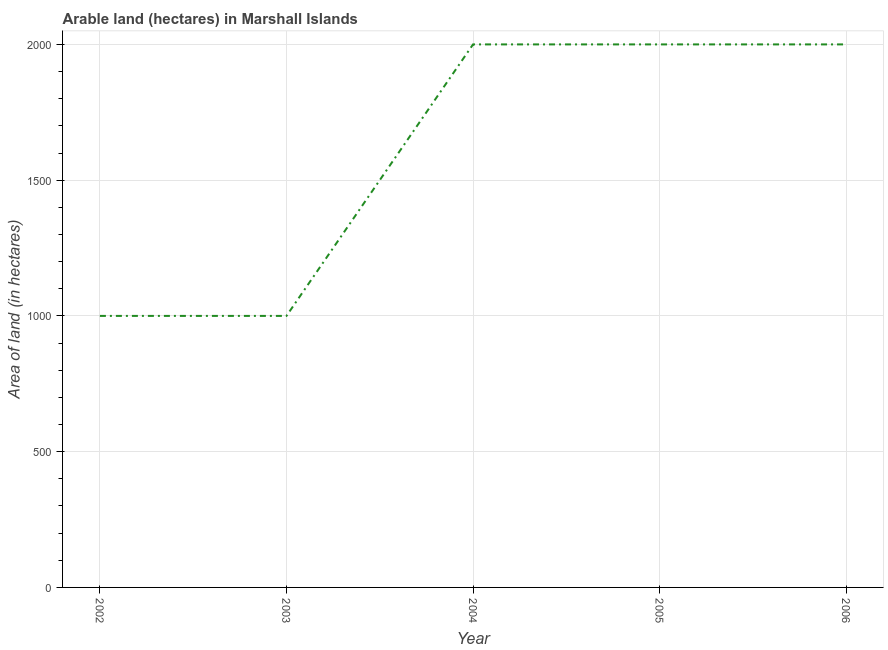What is the area of land in 2006?
Provide a succinct answer. 2000. Across all years, what is the minimum area of land?
Give a very brief answer. 1000. In which year was the area of land minimum?
Provide a succinct answer. 2002. What is the sum of the area of land?
Keep it short and to the point. 8000. What is the difference between the area of land in 2002 and 2005?
Your response must be concise. -1000. What is the average area of land per year?
Provide a short and direct response. 1600. What is the median area of land?
Offer a very short reply. 2000. In how many years, is the area of land greater than 500 hectares?
Keep it short and to the point. 5. What is the difference between the highest and the lowest area of land?
Keep it short and to the point. 1000. Does the area of land monotonically increase over the years?
Offer a very short reply. No. How many lines are there?
Provide a short and direct response. 1. Are the values on the major ticks of Y-axis written in scientific E-notation?
Provide a succinct answer. No. Does the graph contain grids?
Ensure brevity in your answer.  Yes. What is the title of the graph?
Ensure brevity in your answer.  Arable land (hectares) in Marshall Islands. What is the label or title of the Y-axis?
Give a very brief answer. Area of land (in hectares). What is the Area of land (in hectares) of 2004?
Your answer should be very brief. 2000. What is the difference between the Area of land (in hectares) in 2002 and 2003?
Offer a very short reply. 0. What is the difference between the Area of land (in hectares) in 2002 and 2004?
Your answer should be very brief. -1000. What is the difference between the Area of land (in hectares) in 2002 and 2005?
Keep it short and to the point. -1000. What is the difference between the Area of land (in hectares) in 2002 and 2006?
Provide a succinct answer. -1000. What is the difference between the Area of land (in hectares) in 2003 and 2004?
Make the answer very short. -1000. What is the difference between the Area of land (in hectares) in 2003 and 2005?
Offer a very short reply. -1000. What is the difference between the Area of land (in hectares) in 2003 and 2006?
Provide a succinct answer. -1000. What is the difference between the Area of land (in hectares) in 2004 and 2005?
Keep it short and to the point. 0. What is the difference between the Area of land (in hectares) in 2005 and 2006?
Your response must be concise. 0. What is the ratio of the Area of land (in hectares) in 2002 to that in 2005?
Provide a succinct answer. 0.5. What is the ratio of the Area of land (in hectares) in 2003 to that in 2006?
Give a very brief answer. 0.5. What is the ratio of the Area of land (in hectares) in 2004 to that in 2005?
Ensure brevity in your answer.  1. What is the ratio of the Area of land (in hectares) in 2005 to that in 2006?
Offer a terse response. 1. 